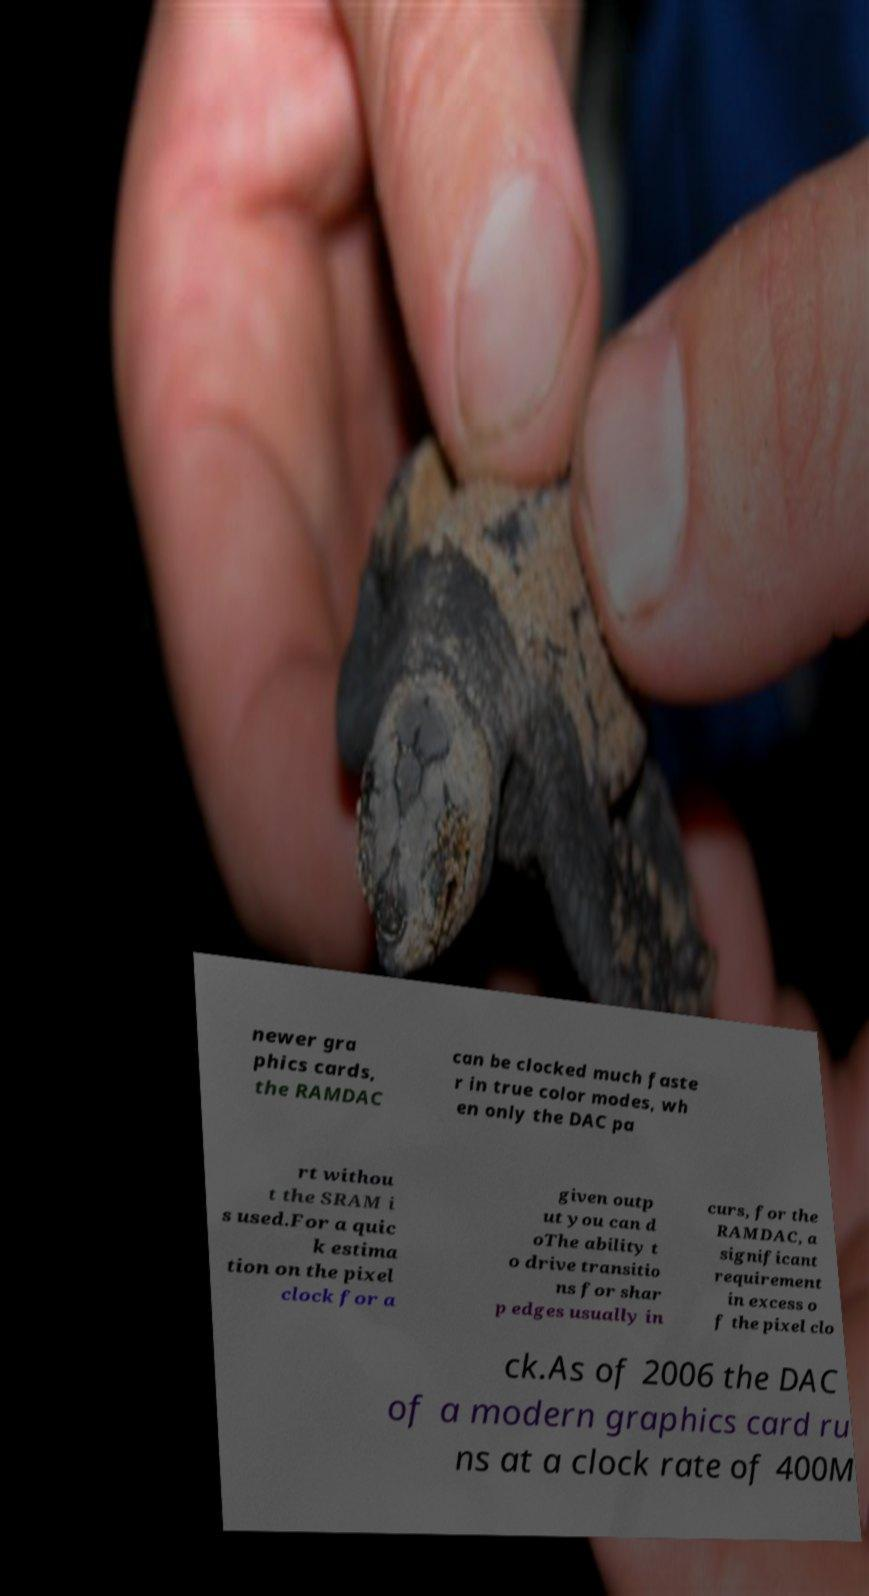Please read and relay the text visible in this image. What does it say? newer gra phics cards, the RAMDAC can be clocked much faste r in true color modes, wh en only the DAC pa rt withou t the SRAM i s used.For a quic k estima tion on the pixel clock for a given outp ut you can d oThe ability t o drive transitio ns for shar p edges usually in curs, for the RAMDAC, a significant requirement in excess o f the pixel clo ck.As of 2006 the DAC of a modern graphics card ru ns at a clock rate of 400M 